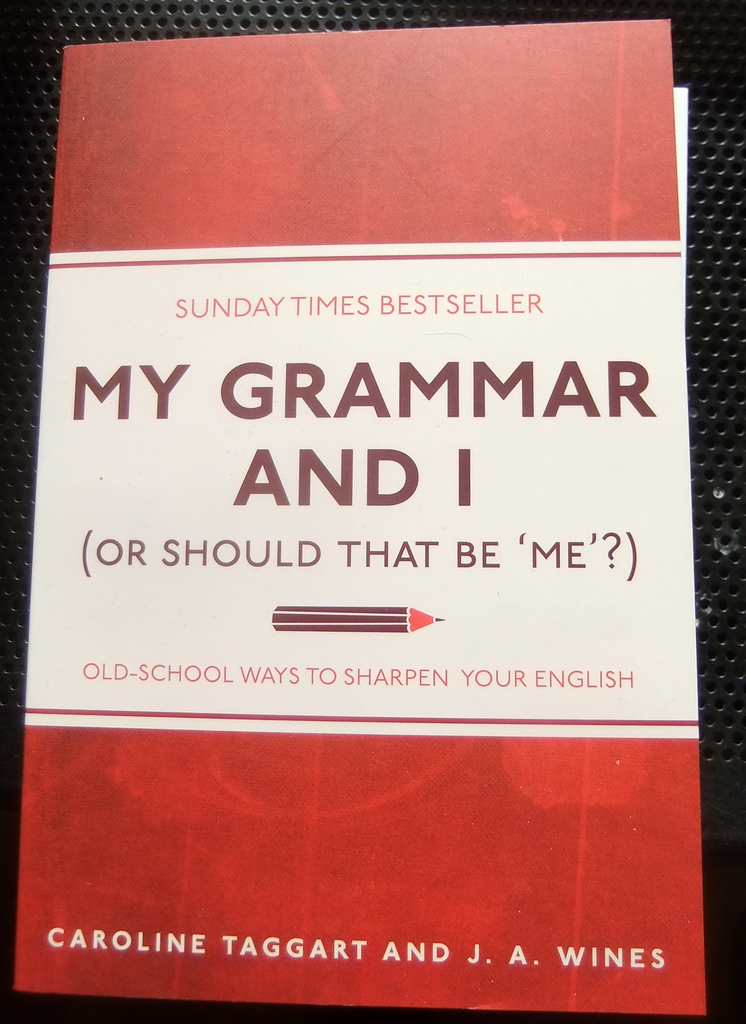Analyze the image in a comprehensive and detailed manner. The image prominently displays the book cover for 'My Grammar and I (Or Should That Be 'Me'?)' authored by Caroline Taggart and J.A. Wines. The cover uses a striking red tone combined with white lettering, making the text highly visible and attention-grabbing. Emphasized as a 'Sunday Times Bestseller,' this marker signals wide acceptance and endorsement from a reputable publication. Beneath the main title, the subtitle 'Old-School Ways to Sharpen Your English' suggests a traditional approach to improving English skills, hinting at content that could include grammar rules, usage examples, and stylistic advice aimed at refining the reader's linguistic capabilities. Notably, a black arrow directs the reader's attention towards the subtitle, likely symbolizing the directional 'corrections' or guidance on proper English usage the book offers. 